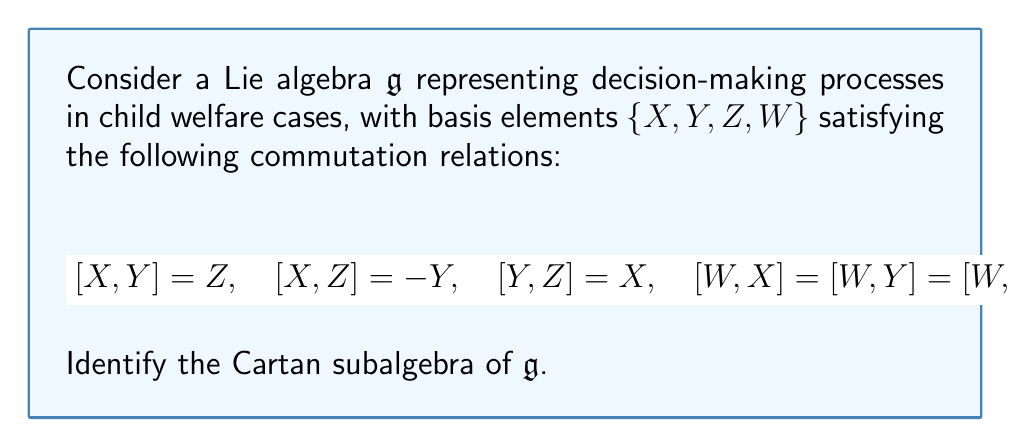Solve this math problem. To identify the Cartan subalgebra of the given Lie algebra $\mathfrak{g}$, we need to follow these steps:

1. Recall that a Cartan subalgebra is a maximal abelian subalgebra consisting of semisimple elements.

2. Observe that $\{X, Y, Z\}$ form a subalgebra isomorphic to $\mathfrak{so}(3)$, the Lie algebra of 3D rotations. This represents the dynamic interplay of factors in child welfare decision-making.

3. Note that $W$ commutes with all other elements, representing a constant factor in the decision process.

4. In $\mathfrak{so}(3)$, any one-dimensional subspace is a Cartan subalgebra. Let's choose the subspace spanned by $Z$.

5. Since $W$ commutes with all elements, it can be added to our Cartan subalgebra without violating the abelian property.

6. Therefore, the subspace spanned by $\{Z, W\}$ is a maximal abelian subalgebra.

7. To verify semisimplicity, we need to check that $ad_Z$ and $ad_W$ are diagonalizable:

   $ad_Z(X) = -Y, \quad ad_Z(Y) = X, \quad ad_Z(Z) = 0, \quad ad_Z(W) = 0$
   $ad_W(X) = ad_W(Y) = ad_W(Z) = ad_W(W) = 0$

   Both are indeed diagonalizable.

Thus, the subspace spanned by $\{Z, W\}$ is the Cartan subalgebra of $\mathfrak{g}$.
Answer: The Cartan subalgebra of $\mathfrak{g}$ is $\mathfrak{h} = \text{span}\{Z, W\}$. 